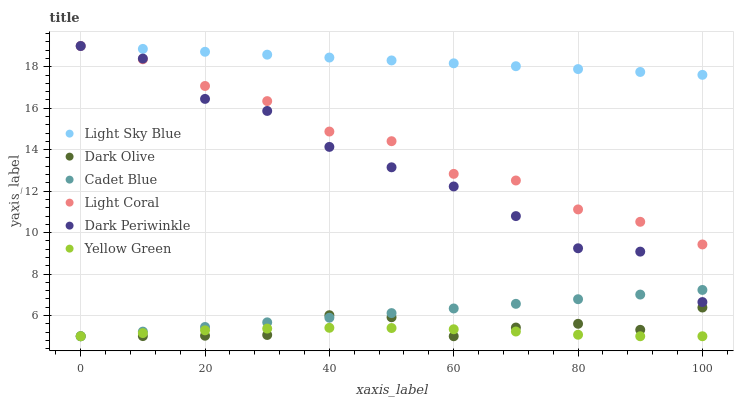Does Yellow Green have the minimum area under the curve?
Answer yes or no. Yes. Does Light Sky Blue have the maximum area under the curve?
Answer yes or no. Yes. Does Dark Olive have the minimum area under the curve?
Answer yes or no. No. Does Dark Olive have the maximum area under the curve?
Answer yes or no. No. Is Cadet Blue the smoothest?
Answer yes or no. Yes. Is Dark Periwinkle the roughest?
Answer yes or no. Yes. Is Yellow Green the smoothest?
Answer yes or no. No. Is Yellow Green the roughest?
Answer yes or no. No. Does Cadet Blue have the lowest value?
Answer yes or no. Yes. Does Light Coral have the lowest value?
Answer yes or no. No. Does Dark Periwinkle have the highest value?
Answer yes or no. Yes. Does Dark Olive have the highest value?
Answer yes or no. No. Is Yellow Green less than Dark Periwinkle?
Answer yes or no. Yes. Is Dark Periwinkle greater than Yellow Green?
Answer yes or no. Yes. Does Dark Periwinkle intersect Light Sky Blue?
Answer yes or no. Yes. Is Dark Periwinkle less than Light Sky Blue?
Answer yes or no. No. Is Dark Periwinkle greater than Light Sky Blue?
Answer yes or no. No. Does Yellow Green intersect Dark Periwinkle?
Answer yes or no. No. 